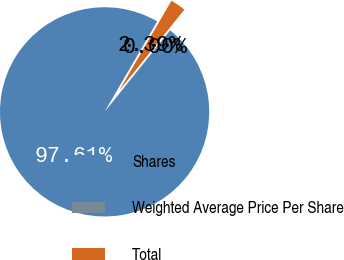<chart> <loc_0><loc_0><loc_500><loc_500><pie_chart><fcel>Shares<fcel>Weighted Average Price Per Share<fcel>Total<nl><fcel>97.61%<fcel>0.0%<fcel>2.39%<nl></chart> 